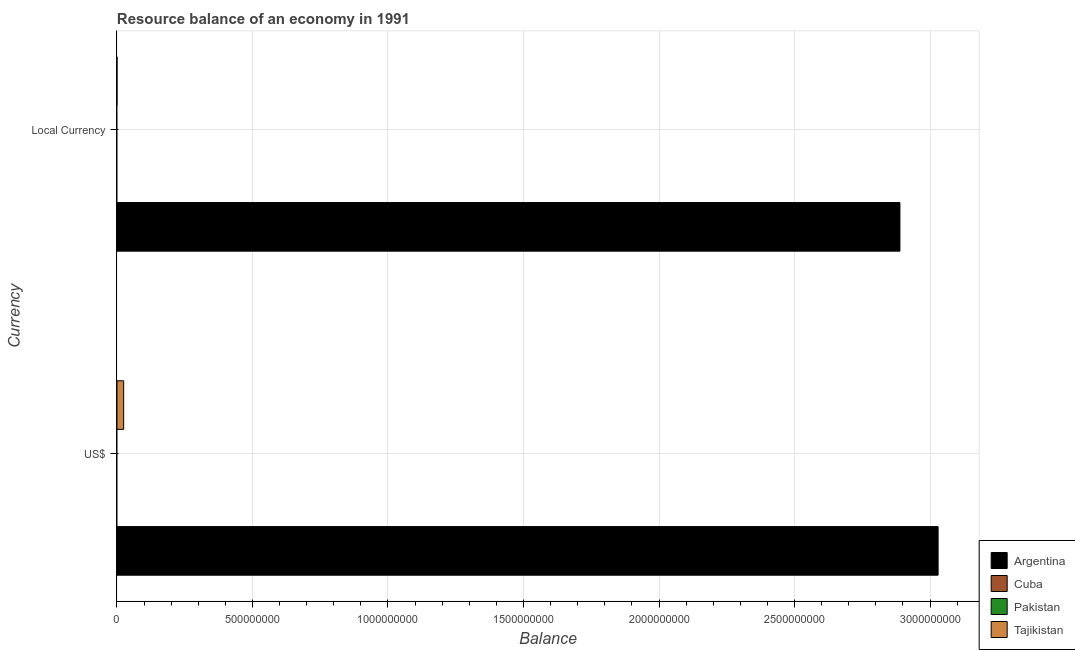How many groups of bars are there?
Make the answer very short. 2. What is the label of the 1st group of bars from the top?
Ensure brevity in your answer.  Local Currency. What is the resource balance in constant us$ in Argentina?
Offer a very short reply. 2.89e+09. Across all countries, what is the maximum resource balance in constant us$?
Provide a short and direct response. 2.89e+09. In which country was the resource balance in us$ maximum?
Give a very brief answer. Argentina. What is the total resource balance in constant us$ in the graph?
Keep it short and to the point. 2.89e+09. What is the difference between the resource balance in constant us$ in Tajikistan and that in Argentina?
Your response must be concise. -2.89e+09. What is the difference between the resource balance in us$ in Tajikistan and the resource balance in constant us$ in Cuba?
Your response must be concise. 2.47e+07. What is the average resource balance in constant us$ per country?
Your answer should be very brief. 7.22e+08. What is the difference between the resource balance in constant us$ and resource balance in us$ in Argentina?
Ensure brevity in your answer.  -1.41e+08. In how many countries, is the resource balance in constant us$ greater than 1300000000 units?
Ensure brevity in your answer.  1. What is the ratio of the resource balance in us$ in Argentina to that in Tajikistan?
Provide a succinct answer. 122.43. Is the resource balance in us$ in Tajikistan less than that in Argentina?
Ensure brevity in your answer.  Yes. In how many countries, is the resource balance in us$ greater than the average resource balance in us$ taken over all countries?
Provide a succinct answer. 1. How many bars are there?
Your answer should be very brief. 4. Are all the bars in the graph horizontal?
Your response must be concise. Yes. How many countries are there in the graph?
Offer a terse response. 4. Are the values on the major ticks of X-axis written in scientific E-notation?
Ensure brevity in your answer.  No. Does the graph contain any zero values?
Your answer should be very brief. Yes. Does the graph contain grids?
Provide a short and direct response. Yes. What is the title of the graph?
Your answer should be compact. Resource balance of an economy in 1991. Does "Equatorial Guinea" appear as one of the legend labels in the graph?
Your response must be concise. No. What is the label or title of the X-axis?
Your answer should be very brief. Balance. What is the label or title of the Y-axis?
Your answer should be compact. Currency. What is the Balance of Argentina in US$?
Give a very brief answer. 3.03e+09. What is the Balance in Cuba in US$?
Keep it short and to the point. 0. What is the Balance in Tajikistan in US$?
Ensure brevity in your answer.  2.47e+07. What is the Balance of Argentina in Local Currency?
Your answer should be compact. 2.89e+09. What is the Balance of Tajikistan in Local Currency?
Provide a succinct answer. 1320. Across all Currency, what is the maximum Balance in Argentina?
Give a very brief answer. 3.03e+09. Across all Currency, what is the maximum Balance in Tajikistan?
Provide a short and direct response. 2.47e+07. Across all Currency, what is the minimum Balance of Argentina?
Offer a very short reply. 2.89e+09. Across all Currency, what is the minimum Balance in Tajikistan?
Provide a succinct answer. 1320. What is the total Balance in Argentina in the graph?
Make the answer very short. 5.92e+09. What is the total Balance of Tajikistan in the graph?
Your answer should be compact. 2.47e+07. What is the difference between the Balance of Argentina in US$ and that in Local Currency?
Keep it short and to the point. 1.41e+08. What is the difference between the Balance in Tajikistan in US$ and that in Local Currency?
Make the answer very short. 2.47e+07. What is the difference between the Balance of Argentina in US$ and the Balance of Tajikistan in Local Currency?
Your answer should be very brief. 3.03e+09. What is the average Balance of Argentina per Currency?
Ensure brevity in your answer.  2.96e+09. What is the average Balance in Tajikistan per Currency?
Your response must be concise. 1.24e+07. What is the difference between the Balance of Argentina and Balance of Tajikistan in US$?
Your answer should be very brief. 3.01e+09. What is the difference between the Balance of Argentina and Balance of Tajikistan in Local Currency?
Your answer should be compact. 2.89e+09. What is the ratio of the Balance in Argentina in US$ to that in Local Currency?
Give a very brief answer. 1.05. What is the ratio of the Balance in Tajikistan in US$ to that in Local Currency?
Your answer should be very brief. 1.87e+04. What is the difference between the highest and the second highest Balance in Argentina?
Keep it short and to the point. 1.41e+08. What is the difference between the highest and the second highest Balance in Tajikistan?
Your answer should be very brief. 2.47e+07. What is the difference between the highest and the lowest Balance of Argentina?
Your answer should be very brief. 1.41e+08. What is the difference between the highest and the lowest Balance of Tajikistan?
Your answer should be very brief. 2.47e+07. 